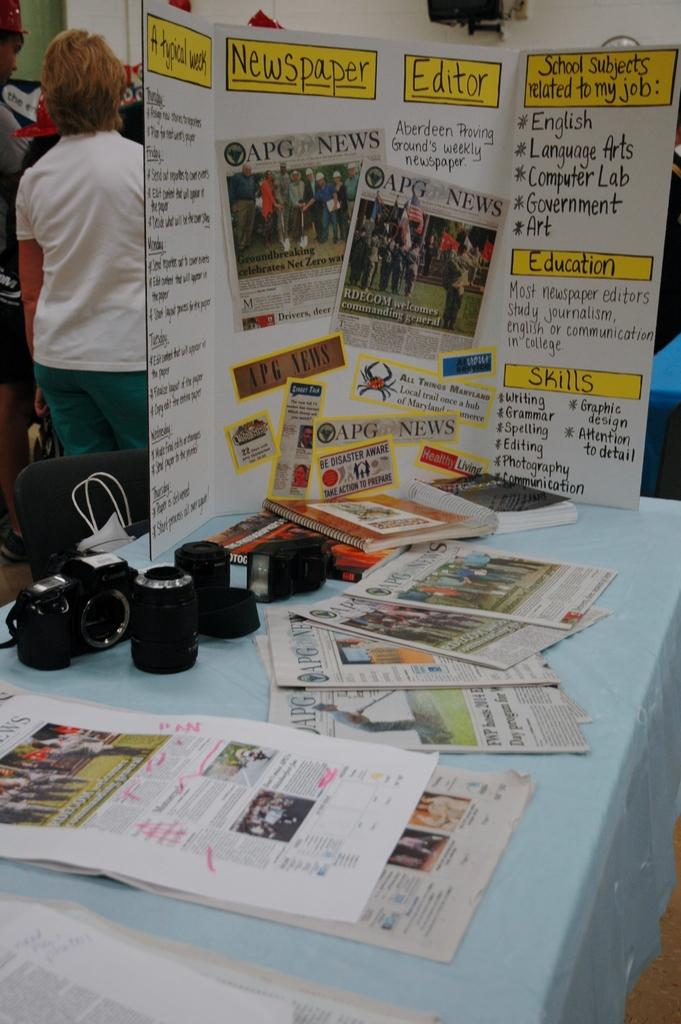<image>
Give a short and clear explanation of the subsequent image. APG newspaper on a white poster board with education and skills wrote on the front. 